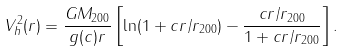<formula> <loc_0><loc_0><loc_500><loc_500>V ^ { 2 } _ { h } ( r ) = \frac { G M _ { 2 0 0 } } { g ( c ) r } \left [ \ln ( 1 + c r / r _ { 2 0 0 } ) - \frac { c r / r _ { 2 0 0 } } { 1 + c r / r _ { 2 0 0 } } \right ] .</formula> 